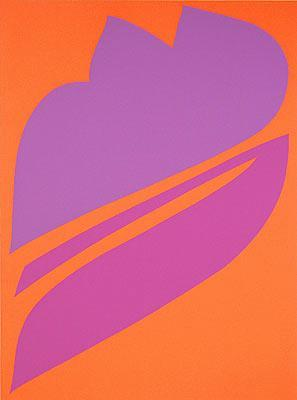How might this piece fit into the broader trends in abstract art? This piece is emblematic of modern abstract art's exploration of color and form to evoke emotion and provoke thought. Abstract art often moves away from direct representation, focusing instead on the power of colors and shapes to communicate deeper feelings or ideas. This artwork, with its bold color contrast and minimalistic style, aligns well with trends that value emotional impact and simplicity, encouraging a personal interaction between the viewer and the art. 